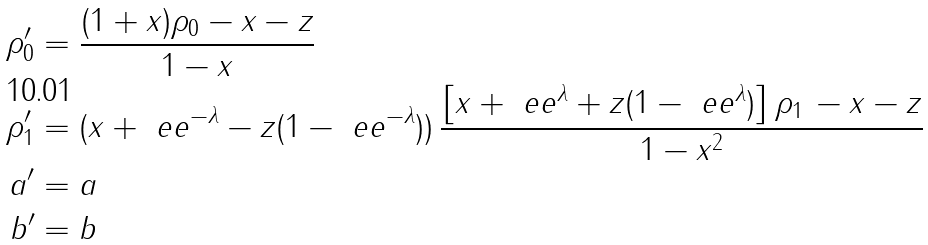<formula> <loc_0><loc_0><loc_500><loc_500>\rho ^ { \prime } _ { 0 } & = \frac { ( 1 + x ) \rho _ { 0 } - x - z } { 1 - x } \\ \rho ^ { \prime } _ { 1 } & = ( x + \ e e ^ { - \lambda } - z ( 1 - \ e e ^ { - \lambda } ) ) \, \frac { \left [ x + \ e e ^ { \lambda } + z ( 1 - \ e e ^ { \lambda } ) \right ] \rho _ { 1 } \, - x - z } { 1 - x ^ { 2 } } \\ a ^ { \prime } & = a \\ b ^ { \prime } & = b</formula> 